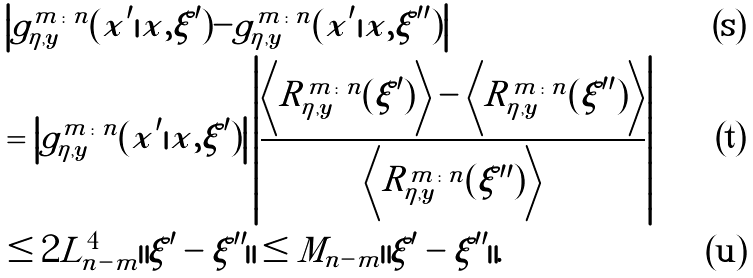Convert formula to latex. <formula><loc_0><loc_0><loc_500><loc_500>& \left | g _ { \eta , \boldsymbol y } ^ { m \colon n } ( x ^ { \prime } | x , \xi ^ { \prime } ) - g _ { \eta , \boldsymbol y } ^ { m \colon n } ( x ^ { \prime } | x , \xi ^ { \prime \prime } ) \right | \\ & = \left | g _ { \eta , \boldsymbol y } ^ { m \colon n } ( x ^ { \prime } | x , \xi ^ { \prime } ) \right | \left | \frac { \left \langle R _ { \eta , \boldsymbol y } ^ { m \colon n } ( \xi ^ { \prime } ) \right \rangle - \left \langle R _ { \eta , \boldsymbol y } ^ { m \colon n } ( \xi ^ { \prime \prime } ) \right \rangle } { \left \langle R _ { \eta , \boldsymbol y } ^ { m \colon n } ( \xi ^ { \prime \prime } ) \right \rangle } \right | \\ & \leq 2 \tilde { L } _ { n - m } ^ { 4 } \| \xi ^ { \prime } - \xi ^ { \prime \prime } \| \leq \tilde { M } _ { n - m } \| \xi ^ { \prime } - \xi ^ { \prime \prime } \| .</formula> 